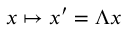Convert formula to latex. <formula><loc_0><loc_0><loc_500><loc_500>x \mapsto x ^ { \prime } = \Lambda x</formula> 